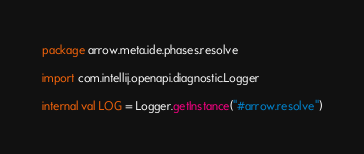<code> <loc_0><loc_0><loc_500><loc_500><_Kotlin_>package arrow.meta.ide.phases.resolve

import com.intellij.openapi.diagnostic.Logger

internal val LOG = Logger.getInstance("#arrow.resolve")
</code> 